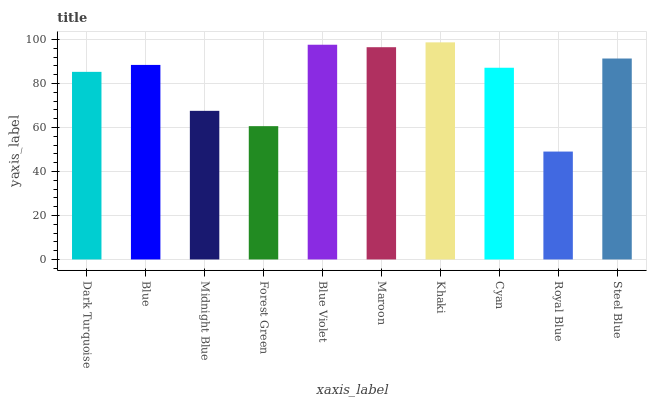Is Blue the minimum?
Answer yes or no. No. Is Blue the maximum?
Answer yes or no. No. Is Blue greater than Dark Turquoise?
Answer yes or no. Yes. Is Dark Turquoise less than Blue?
Answer yes or no. Yes. Is Dark Turquoise greater than Blue?
Answer yes or no. No. Is Blue less than Dark Turquoise?
Answer yes or no. No. Is Blue the high median?
Answer yes or no. Yes. Is Cyan the low median?
Answer yes or no. Yes. Is Forest Green the high median?
Answer yes or no. No. Is Steel Blue the low median?
Answer yes or no. No. 